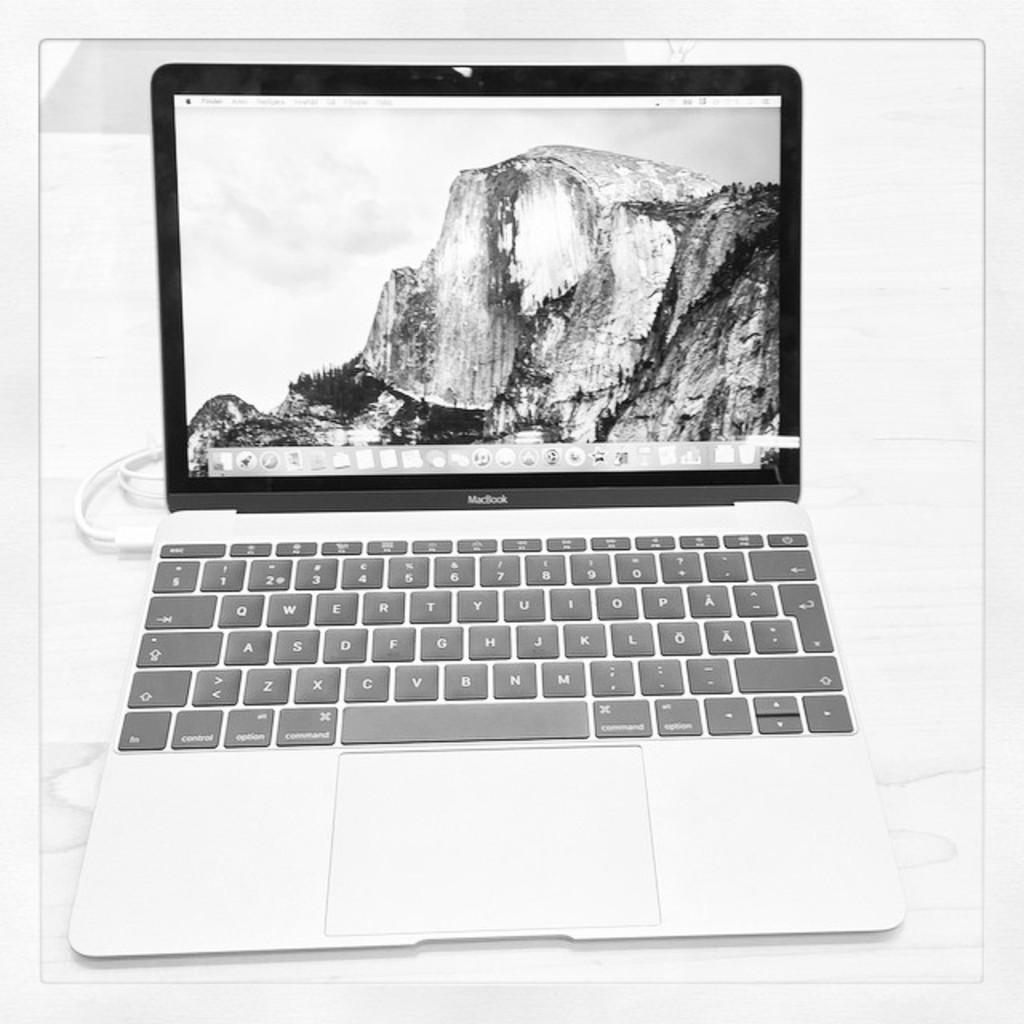Can you describe this image briefly? In this picture we can see a laptop on a platform. 